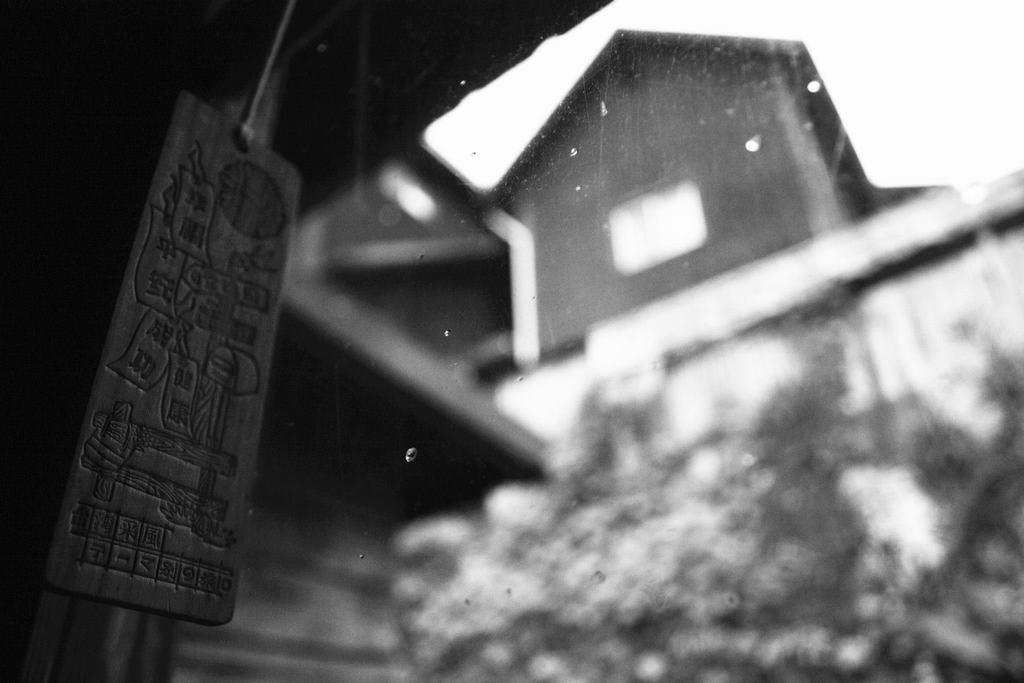What type of object is hanging on the left side of the image? There is a wooden object hanging on the left side of the image. What other type of object can be seen in the image? There is a glass object in the image. What is depicted on the glass object? The glass object appears to show a house and trees, but the clarity is uncertain. How many pieces of popcorn are scattered on the floor in the image? There is no popcorn present in the image. What type of trousers is the person wearing in the image? There is no person or trousers present in the image. 